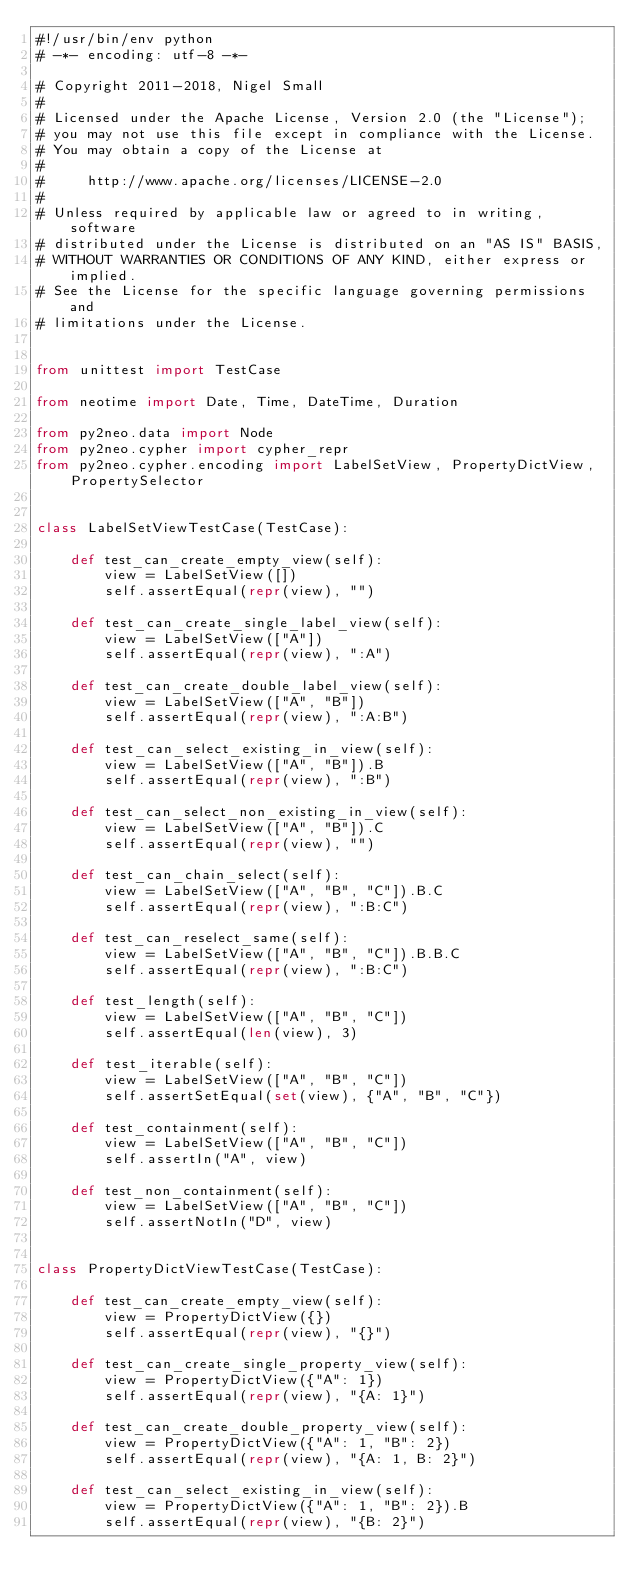<code> <loc_0><loc_0><loc_500><loc_500><_Python_>#!/usr/bin/env python
# -*- encoding: utf-8 -*-

# Copyright 2011-2018, Nigel Small
#
# Licensed under the Apache License, Version 2.0 (the "License");
# you may not use this file except in compliance with the License.
# You may obtain a copy of the License at
#
#     http://www.apache.org/licenses/LICENSE-2.0
#
# Unless required by applicable law or agreed to in writing, software
# distributed under the License is distributed on an "AS IS" BASIS,
# WITHOUT WARRANTIES OR CONDITIONS OF ANY KIND, either express or implied.
# See the License for the specific language governing permissions and
# limitations under the License.


from unittest import TestCase

from neotime import Date, Time, DateTime, Duration

from py2neo.data import Node
from py2neo.cypher import cypher_repr
from py2neo.cypher.encoding import LabelSetView, PropertyDictView, PropertySelector


class LabelSetViewTestCase(TestCase):

    def test_can_create_empty_view(self):
        view = LabelSetView([])
        self.assertEqual(repr(view), "")

    def test_can_create_single_label_view(self):
        view = LabelSetView(["A"])
        self.assertEqual(repr(view), ":A")

    def test_can_create_double_label_view(self):
        view = LabelSetView(["A", "B"])
        self.assertEqual(repr(view), ":A:B")

    def test_can_select_existing_in_view(self):
        view = LabelSetView(["A", "B"]).B
        self.assertEqual(repr(view), ":B")

    def test_can_select_non_existing_in_view(self):
        view = LabelSetView(["A", "B"]).C
        self.assertEqual(repr(view), "")

    def test_can_chain_select(self):
        view = LabelSetView(["A", "B", "C"]).B.C
        self.assertEqual(repr(view), ":B:C")

    def test_can_reselect_same(self):
        view = LabelSetView(["A", "B", "C"]).B.B.C
        self.assertEqual(repr(view), ":B:C")

    def test_length(self):
        view = LabelSetView(["A", "B", "C"])
        self.assertEqual(len(view), 3)

    def test_iterable(self):
        view = LabelSetView(["A", "B", "C"])
        self.assertSetEqual(set(view), {"A", "B", "C"})

    def test_containment(self):
        view = LabelSetView(["A", "B", "C"])
        self.assertIn("A", view)

    def test_non_containment(self):
        view = LabelSetView(["A", "B", "C"])
        self.assertNotIn("D", view)


class PropertyDictViewTestCase(TestCase):

    def test_can_create_empty_view(self):
        view = PropertyDictView({})
        self.assertEqual(repr(view), "{}")

    def test_can_create_single_property_view(self):
        view = PropertyDictView({"A": 1})
        self.assertEqual(repr(view), "{A: 1}")

    def test_can_create_double_property_view(self):
        view = PropertyDictView({"A": 1, "B": 2})
        self.assertEqual(repr(view), "{A: 1, B: 2}")

    def test_can_select_existing_in_view(self):
        view = PropertyDictView({"A": 1, "B": 2}).B
        self.assertEqual(repr(view), "{B: 2}")
</code> 